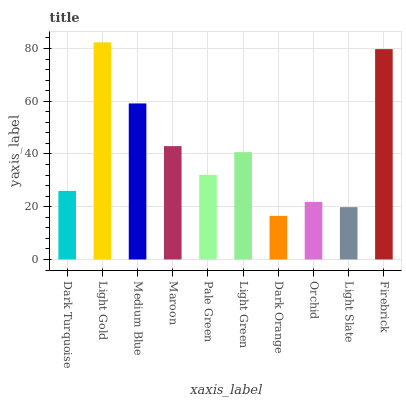Is Medium Blue the minimum?
Answer yes or no. No. Is Medium Blue the maximum?
Answer yes or no. No. Is Light Gold greater than Medium Blue?
Answer yes or no. Yes. Is Medium Blue less than Light Gold?
Answer yes or no. Yes. Is Medium Blue greater than Light Gold?
Answer yes or no. No. Is Light Gold less than Medium Blue?
Answer yes or no. No. Is Light Green the high median?
Answer yes or no. Yes. Is Pale Green the low median?
Answer yes or no. Yes. Is Pale Green the high median?
Answer yes or no. No. Is Dark Orange the low median?
Answer yes or no. No. 